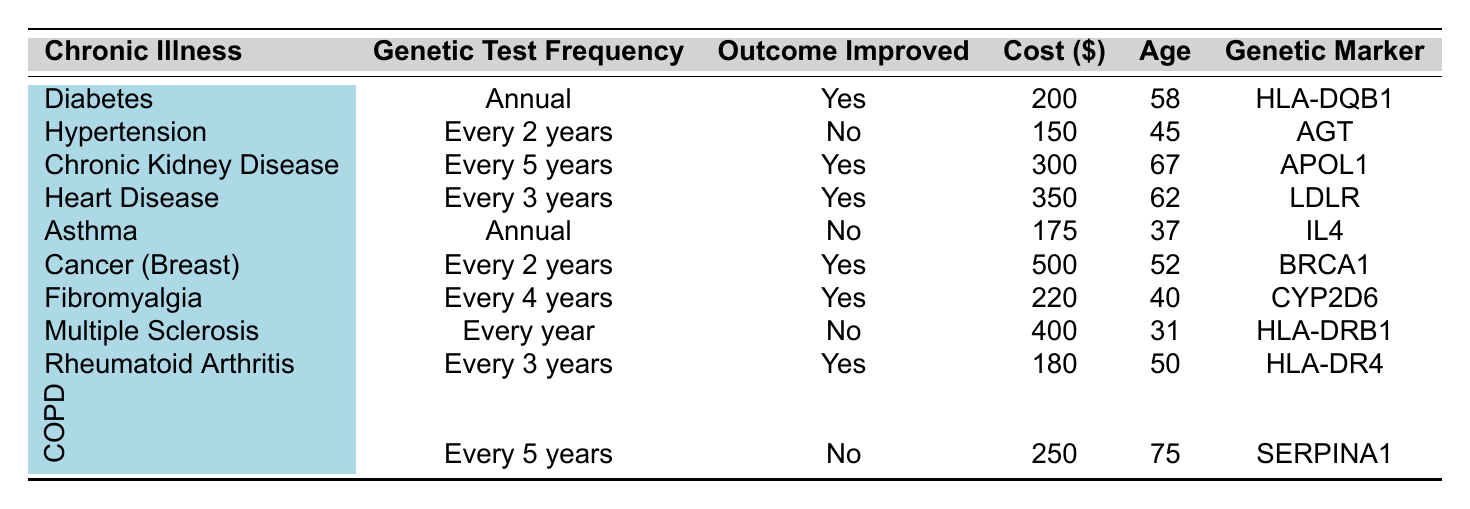What is the genetic test frequency for patients with Heart Disease? Referring to the table, for Heart Disease, the genetic test frequency is listed as "Every 3 years."
Answer: Every 3 years How many patients experienced an improvement in outcomes after genetic testing? By reviewing the table, the patients who experienced an improvement are: Diabetes, Chronic Kidney Disease, Heart Disease, Cancer (Breast), Fibromyalgia, and Rheumatoid Arthritis, totaling 6 patients.
Answer: 6 What is the age of the patient with the lowest cost for genetic testing? Looking at the cost column, the patient with the lowest cost ($150) is for Hypertension, whose age is 45.
Answer: 45 What is the average cost of genetic testing for patients who had improvement in their outcomes? The patients with improvements in outcomes are Diabetes ($200), Chronic Kidney Disease ($300), Heart Disease ($350), Cancer (Breast) ($500), Fibromyalgia ($220), and Rheumatoid Arthritis ($180). The total cost is 200 + 300 + 350 + 500 + 220 + 180 = 1850. The average cost is 1850 / 6 = 308.33.
Answer: 308.33 Is there an improvement in outcomes for patients with Asthma after genetic testing? The table indicates that for Asthma, the outcome improvement is "No," which means there was no improvement.
Answer: No What percentage of patients showed improvement after genetic testing based on the total number of patients listed? Out of the 10 patients listed, 6 showed improvement. Therefore, the percentage of improvement is (6/10) * 100 = 60%.
Answer: 60% What is the most expensive genetic test among the patients listed? The table shows that the genetic test for Cancer (Breast) has the highest cost at $500.
Answer: $500 How much more does the genetic test for Chronic Kidney Disease cost compared to that for Hypertension? The cost for Chronic Kidney Disease is $300, while for Hypertension it is $150. The difference is 300 - 150 = $150.
Answer: $150 Are there any patients aged above 60 who did not have an improvement in their outcomes? The table shows that the patients above 60 are Chronic Kidney Disease (67, Yes), Heart Disease (62, Yes), and Chronic Obstructive Pulmonary Disease (75, No). Therefore, COPD is the only patient above 60 with no improvement.
Answer: Yes Which chronic illness has the highest average patient age among those that had an outcome improvement? The patients with improvement and their ages are: Diabetes (58), Chronic Kidney Disease (67), Heart Disease (62), Cancer (Breast) (52), Fibromyalgia (40), and Rheumatoid Arthritis (50). The average age is (58 + 67 + 62 + 52 + 40 + 50) / 6 = 54.83. The oldest patient among them is Chronic Kidney Disease with age 67, leading to a conclusion that it has the highest patient age.
Answer: Chronic Kidney Disease 